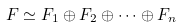<formula> <loc_0><loc_0><loc_500><loc_500>F \simeq F _ { 1 } \oplus F _ { 2 } \oplus \cdots \oplus F _ { n }</formula> 